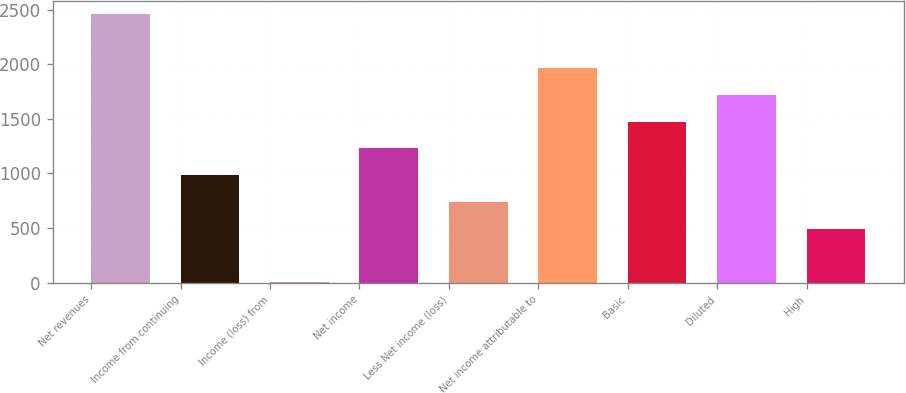Convert chart to OTSL. <chart><loc_0><loc_0><loc_500><loc_500><bar_chart><fcel>Net revenues<fcel>Income from continuing<fcel>Income (loss) from<fcel>Net income<fcel>Less Net income (loss)<fcel>Net income attributable to<fcel>Basic<fcel>Diluted<fcel>High<nl><fcel>2455<fcel>983.2<fcel>2<fcel>1228.5<fcel>737.9<fcel>1964.4<fcel>1473.8<fcel>1719.1<fcel>492.6<nl></chart> 